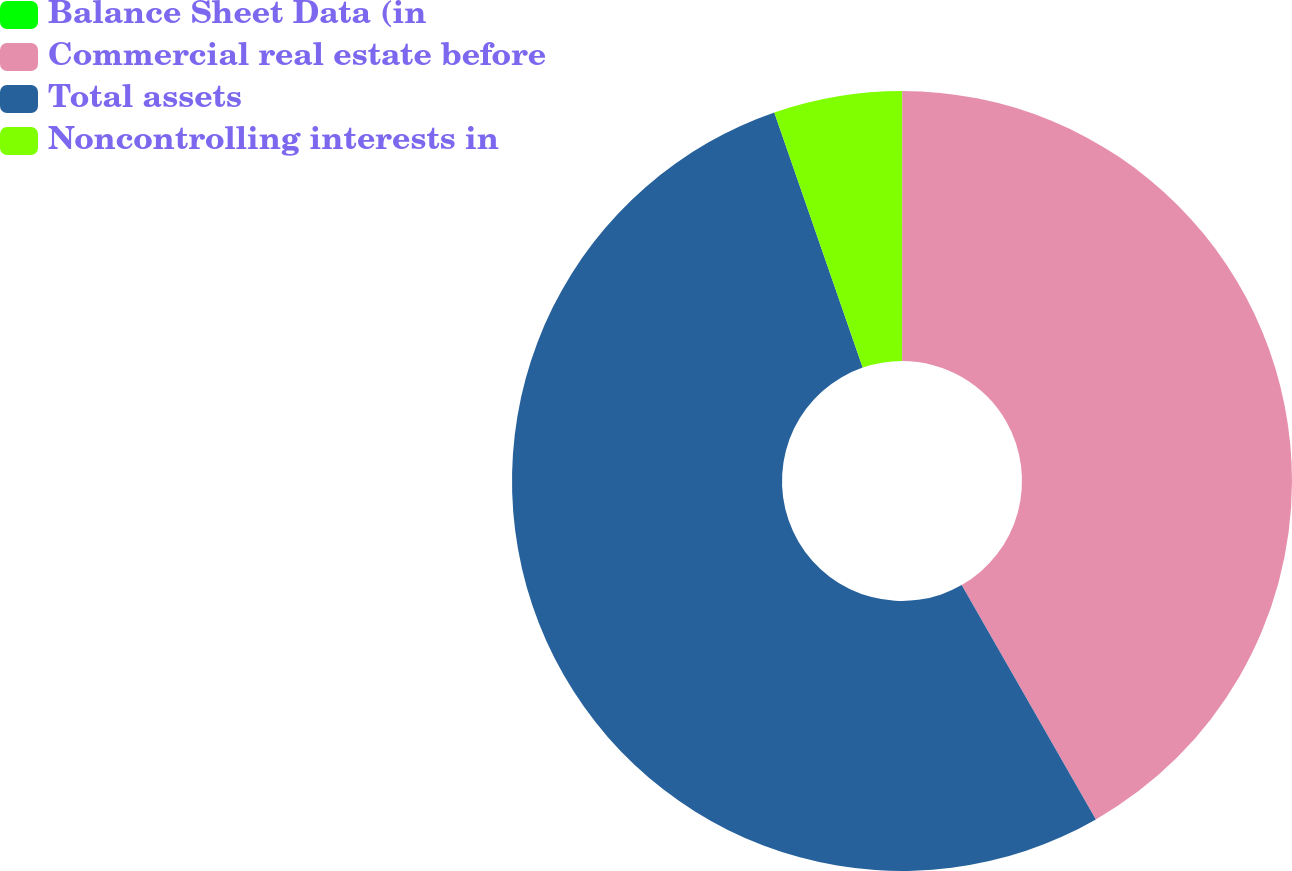Convert chart. <chart><loc_0><loc_0><loc_500><loc_500><pie_chart><fcel>Balance Sheet Data (in<fcel>Commercial real estate before<fcel>Total assets<fcel>Noncontrolling interests in<nl><fcel>0.01%<fcel>41.71%<fcel>52.97%<fcel>5.31%<nl></chart> 